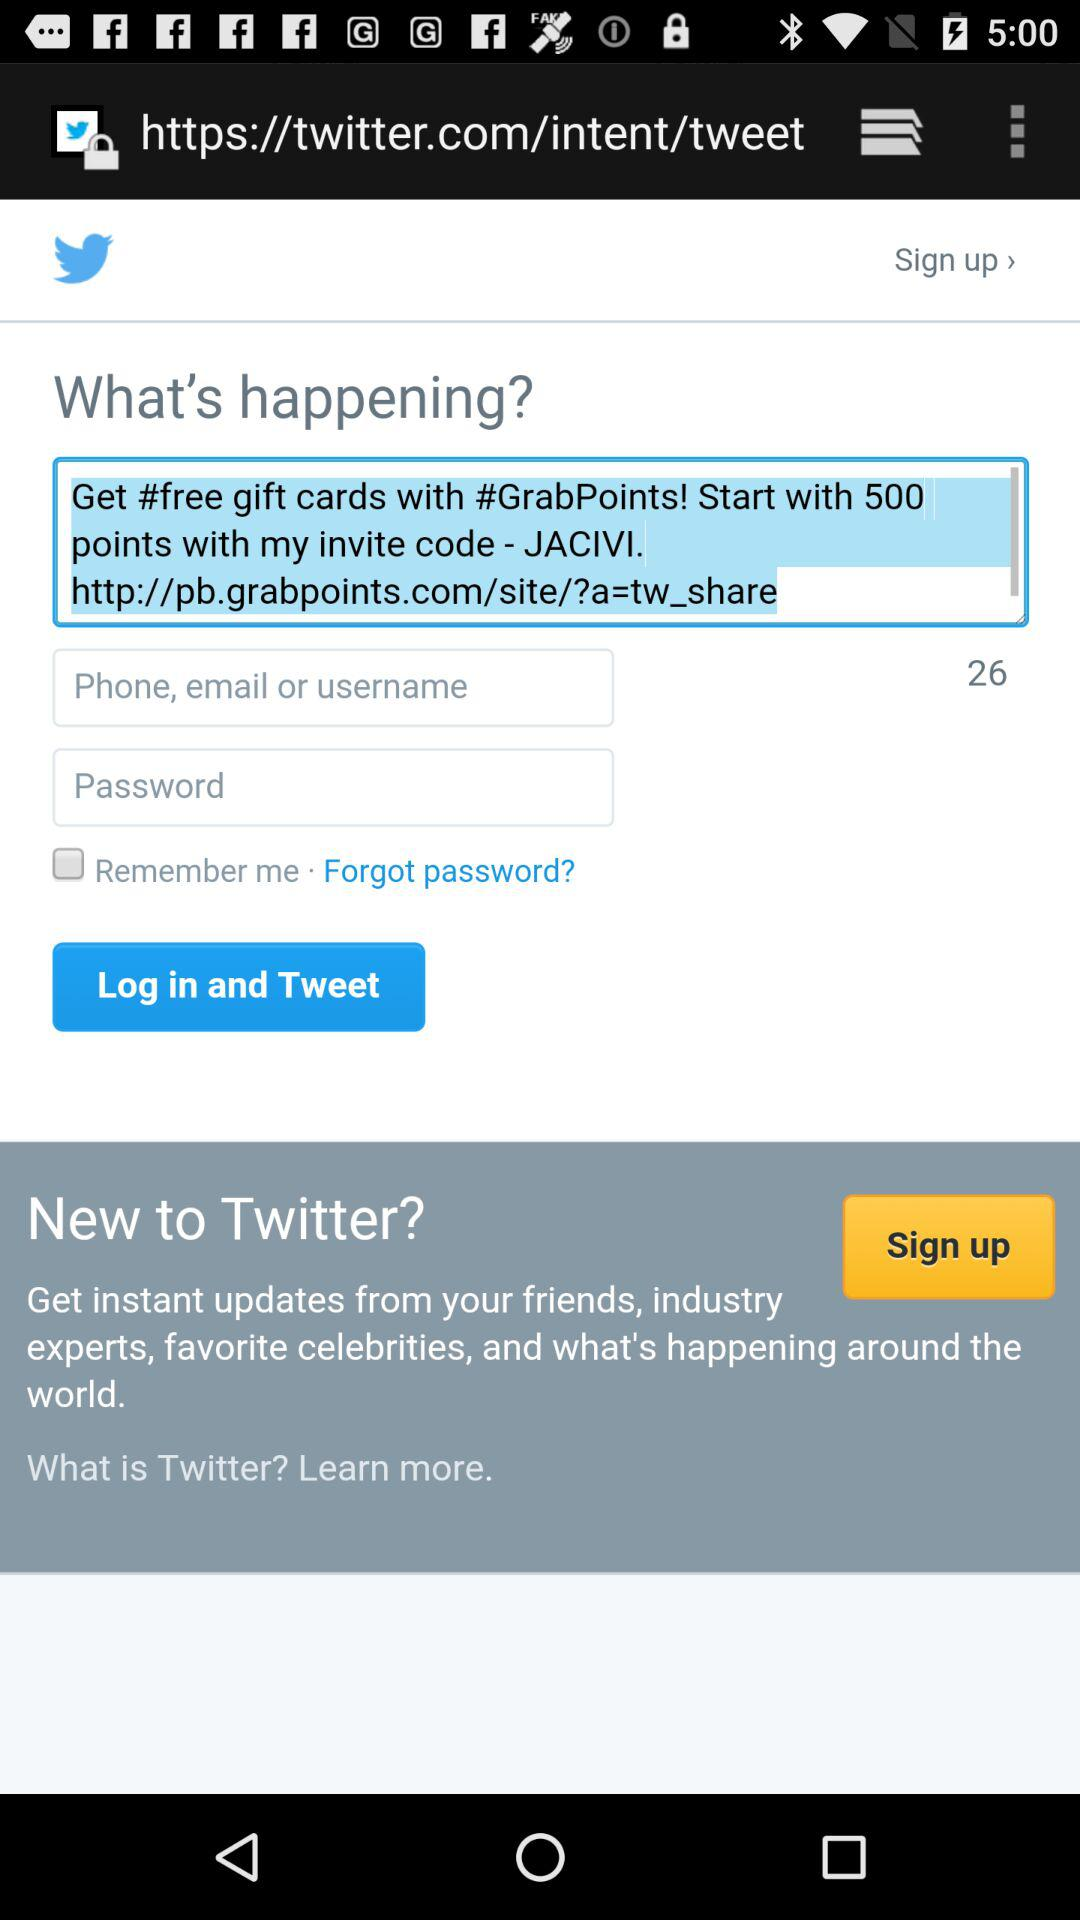What is the name of the application? The name of the application is "Twitter". 